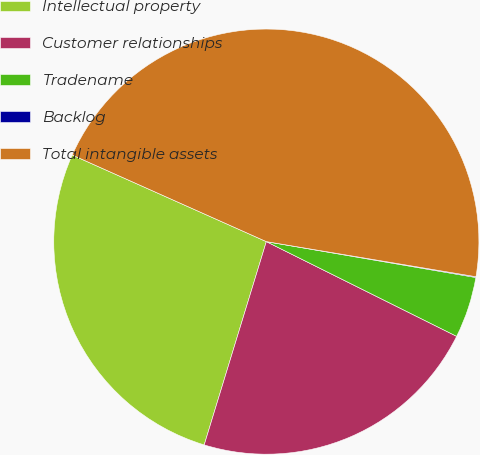<chart> <loc_0><loc_0><loc_500><loc_500><pie_chart><fcel>Intellectual property<fcel>Customer relationships<fcel>Tradename<fcel>Backlog<fcel>Total intangible assets<nl><fcel>26.96%<fcel>22.37%<fcel>4.65%<fcel>0.06%<fcel>45.96%<nl></chart> 